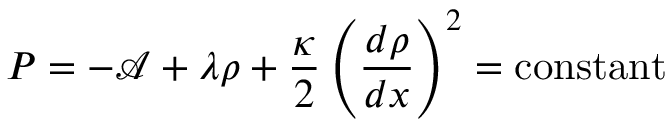<formula> <loc_0><loc_0><loc_500><loc_500>P = - \mathcal { A } + \lambda \rho + \frac { \kappa } { 2 } \left ( \frac { d \rho } { d x } \right ) ^ { 2 } = c o n s t a n t</formula> 